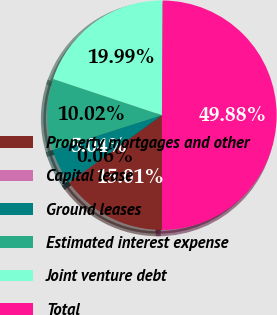<chart> <loc_0><loc_0><loc_500><loc_500><pie_chart><fcel>Property mortgages and other<fcel>Capital lease<fcel>Ground leases<fcel>Estimated interest expense<fcel>Joint venture debt<fcel>Total<nl><fcel>15.01%<fcel>0.06%<fcel>5.04%<fcel>10.02%<fcel>19.99%<fcel>49.88%<nl></chart> 